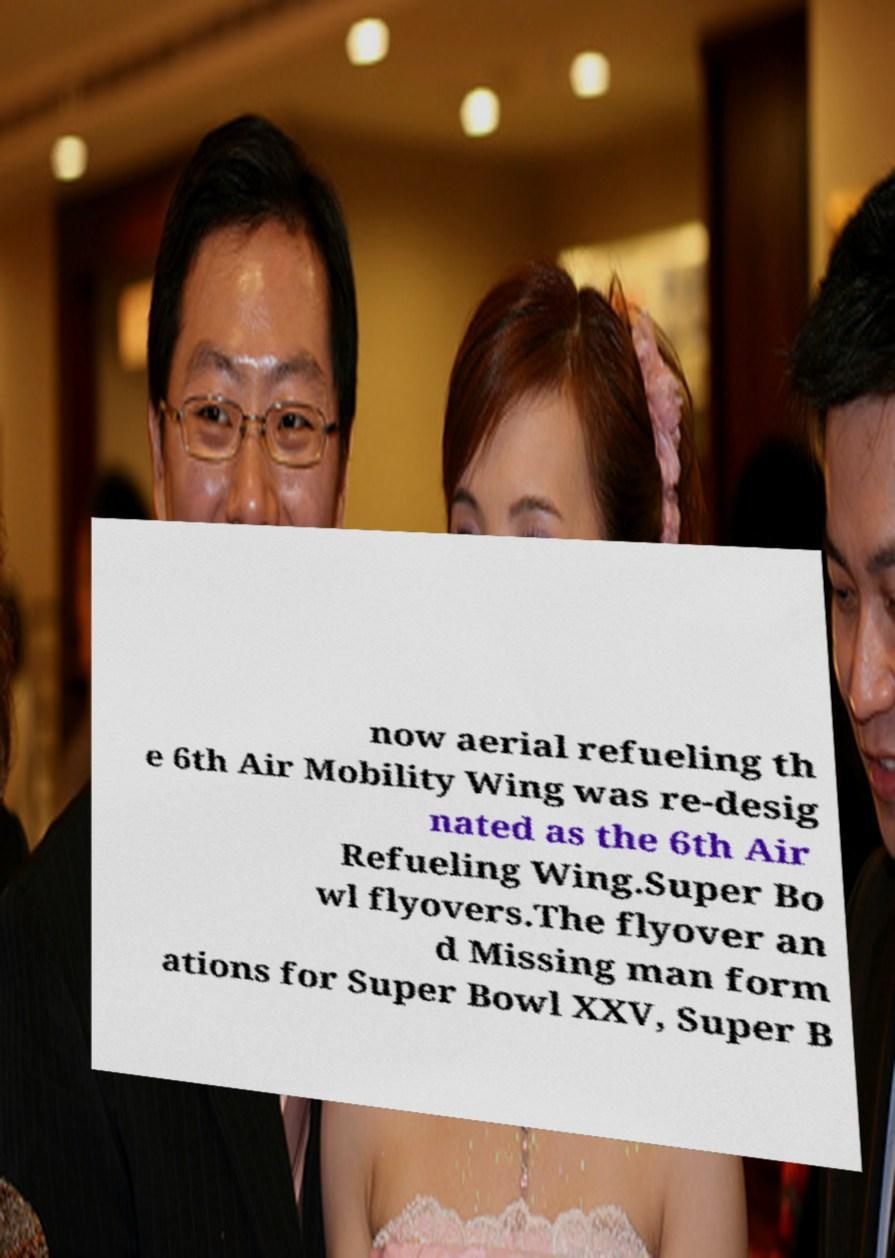For documentation purposes, I need the text within this image transcribed. Could you provide that? now aerial refueling th e 6th Air Mobility Wing was re-desig nated as the 6th Air Refueling Wing.Super Bo wl flyovers.The flyover an d Missing man form ations for Super Bowl XXV, Super B 